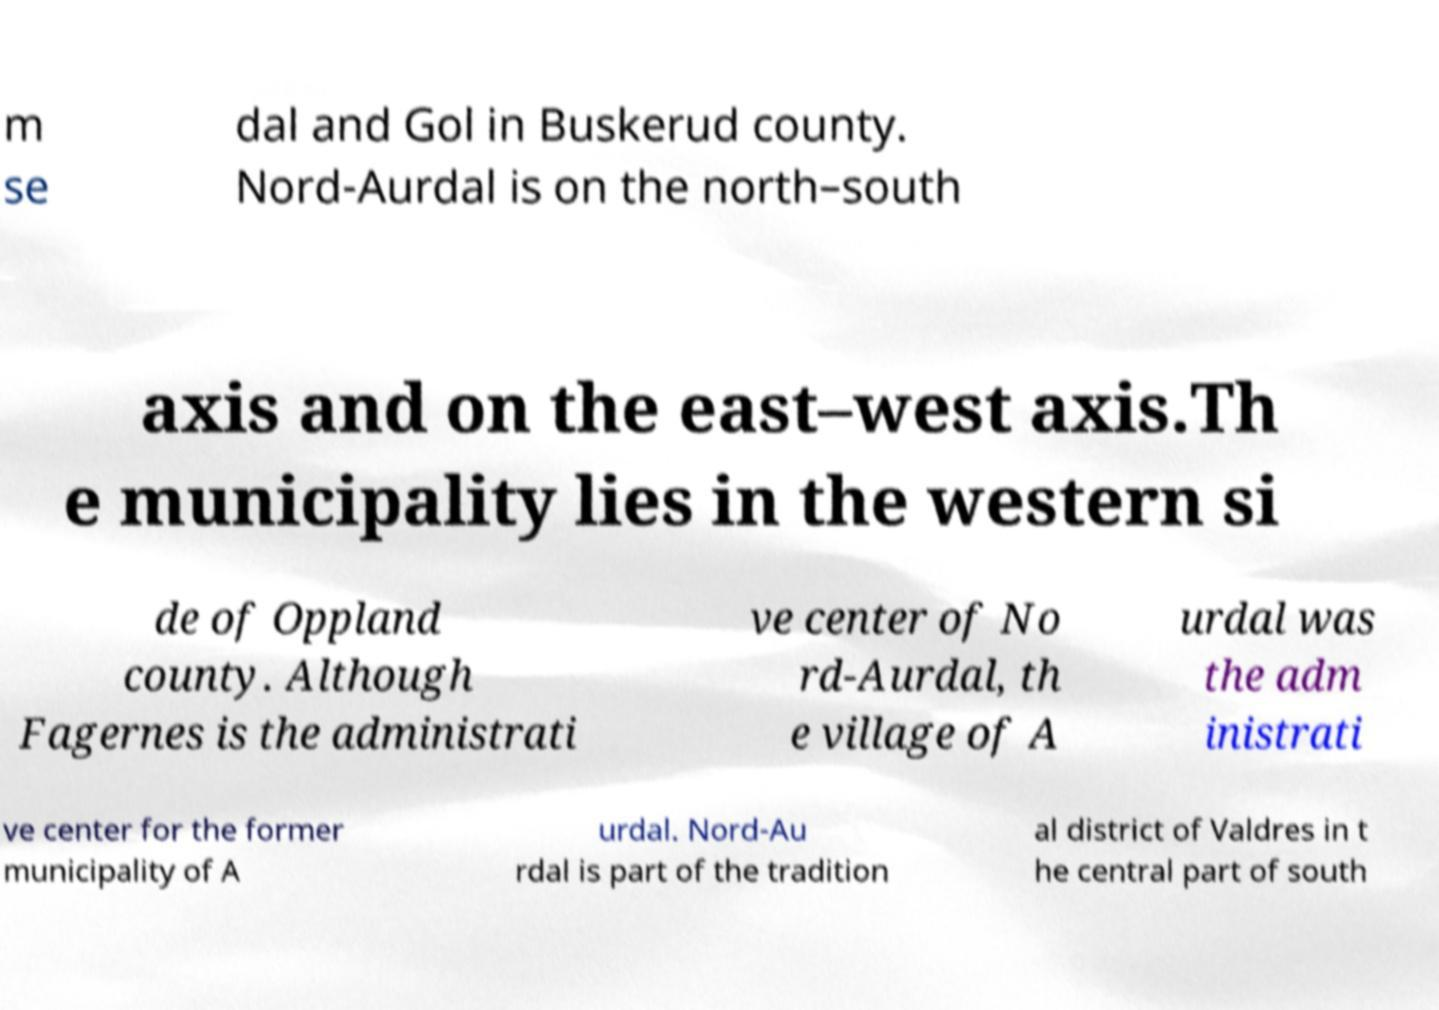Please identify and transcribe the text found in this image. m se dal and Gol in Buskerud county. Nord-Aurdal is on the north–south axis and on the east–west axis.Th e municipality lies in the western si de of Oppland county. Although Fagernes is the administrati ve center of No rd-Aurdal, th e village of A urdal was the adm inistrati ve center for the former municipality of A urdal. Nord-Au rdal is part of the tradition al district of Valdres in t he central part of south 